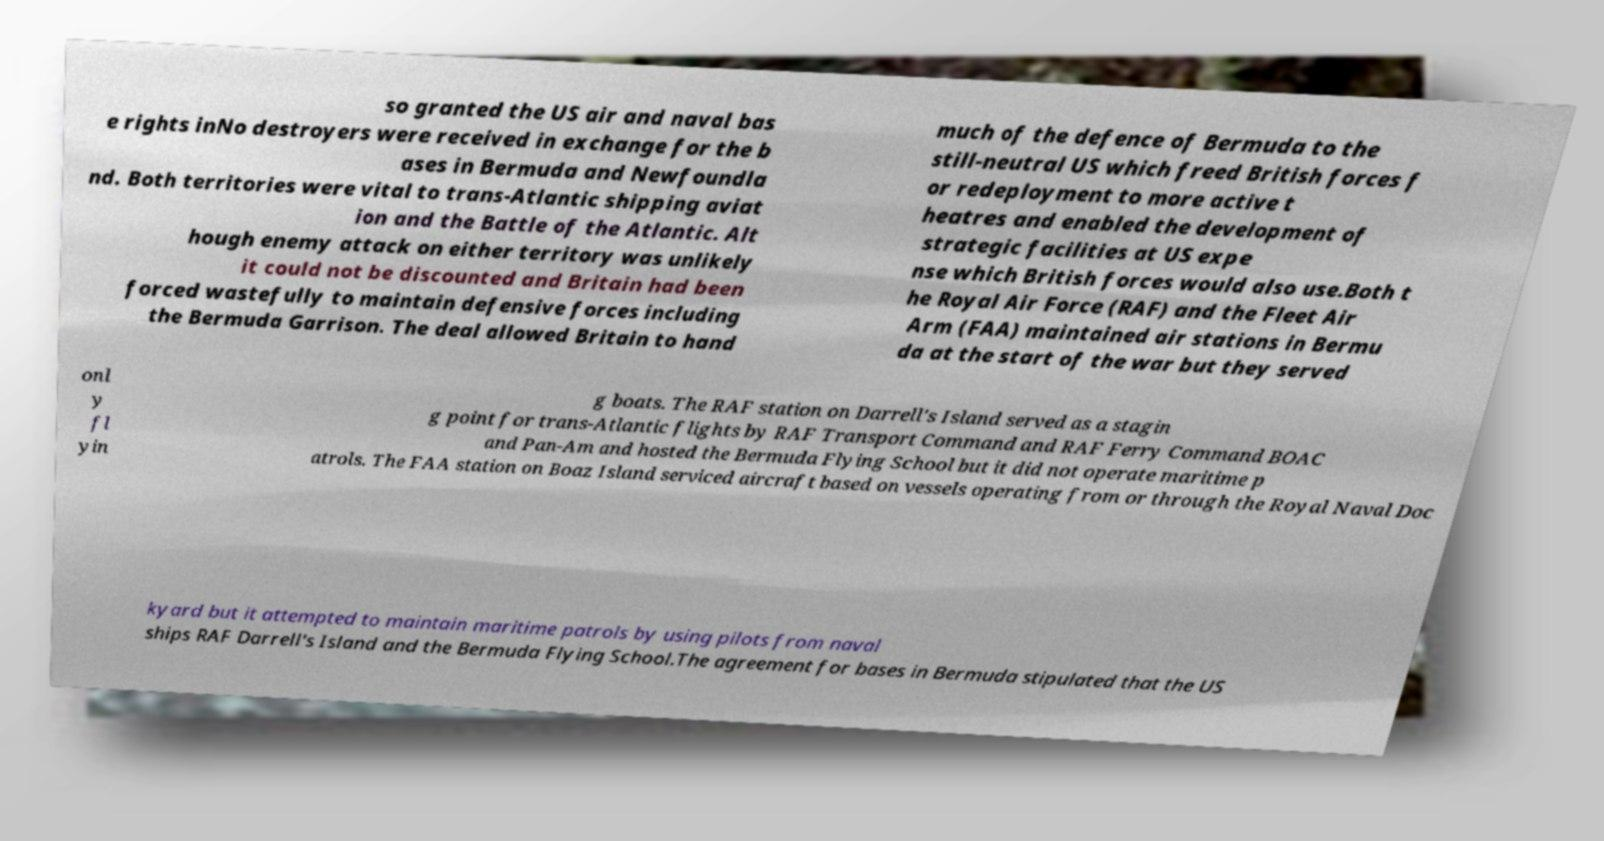I need the written content from this picture converted into text. Can you do that? so granted the US air and naval bas e rights inNo destroyers were received in exchange for the b ases in Bermuda and Newfoundla nd. Both territories were vital to trans-Atlantic shipping aviat ion and the Battle of the Atlantic. Alt hough enemy attack on either territory was unlikely it could not be discounted and Britain had been forced wastefully to maintain defensive forces including the Bermuda Garrison. The deal allowed Britain to hand much of the defence of Bermuda to the still-neutral US which freed British forces f or redeployment to more active t heatres and enabled the development of strategic facilities at US expe nse which British forces would also use.Both t he Royal Air Force (RAF) and the Fleet Air Arm (FAA) maintained air stations in Bermu da at the start of the war but they served onl y fl yin g boats. The RAF station on Darrell's Island served as a stagin g point for trans-Atlantic flights by RAF Transport Command and RAF Ferry Command BOAC and Pan-Am and hosted the Bermuda Flying School but it did not operate maritime p atrols. The FAA station on Boaz Island serviced aircraft based on vessels operating from or through the Royal Naval Doc kyard but it attempted to maintain maritime patrols by using pilots from naval ships RAF Darrell's Island and the Bermuda Flying School.The agreement for bases in Bermuda stipulated that the US 